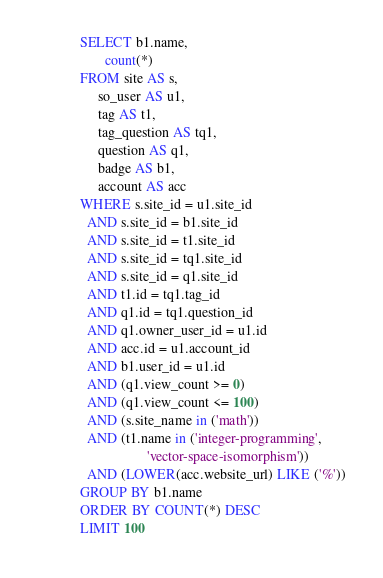Convert code to text. <code><loc_0><loc_0><loc_500><loc_500><_SQL_>SELECT b1.name,
       count(*)
FROM site AS s,
     so_user AS u1,
     tag AS t1,
     tag_question AS tq1,
     question AS q1,
     badge AS b1,
     account AS acc
WHERE s.site_id = u1.site_id
  AND s.site_id = b1.site_id
  AND s.site_id = t1.site_id
  AND s.site_id = tq1.site_id
  AND s.site_id = q1.site_id
  AND t1.id = tq1.tag_id
  AND q1.id = tq1.question_id
  AND q1.owner_user_id = u1.id
  AND acc.id = u1.account_id
  AND b1.user_id = u1.id
  AND (q1.view_count >= 0)
  AND (q1.view_count <= 100)
  AND (s.site_name in ('math'))
  AND (t1.name in ('integer-programming',
                   'vector-space-isomorphism'))
  AND (LOWER(acc.website_url) LIKE ('%'))
GROUP BY b1.name
ORDER BY COUNT(*) DESC
LIMIT 100</code> 